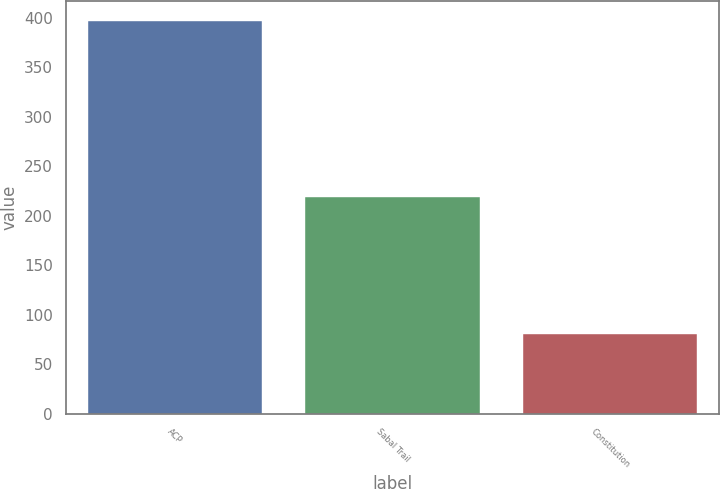Convert chart to OTSL. <chart><loc_0><loc_0><loc_500><loc_500><bar_chart><fcel>ACP<fcel>Sabal Trail<fcel>Constitution<nl><fcel>397<fcel>219<fcel>81<nl></chart> 